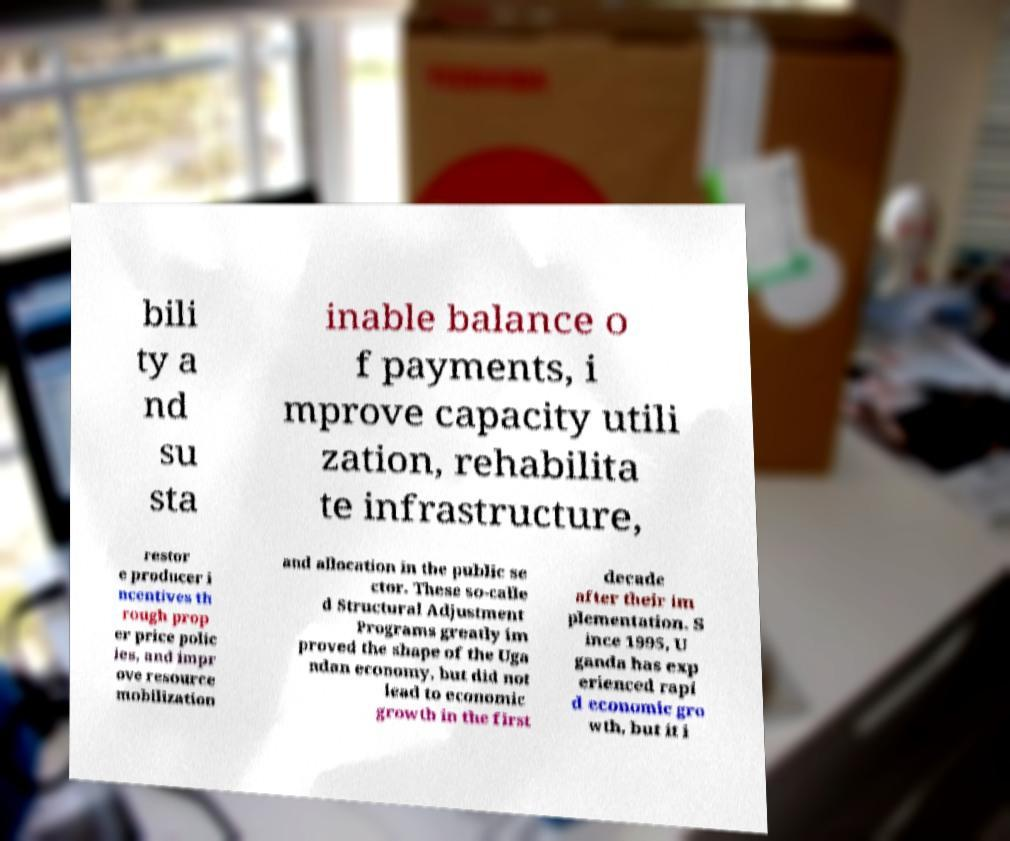Can you read and provide the text displayed in the image?This photo seems to have some interesting text. Can you extract and type it out for me? bili ty a nd su sta inable balance o f payments, i mprove capacity utili zation, rehabilita te infrastructure, restor e producer i ncentives th rough prop er price polic ies, and impr ove resource mobilization and allocation in the public se ctor. These so-calle d Structural Adjustment Programs greatly im proved the shape of the Uga ndan economy, but did not lead to economic growth in the first decade after their im plementation. S ince 1995, U ganda has exp erienced rapi d economic gro wth, but it i 